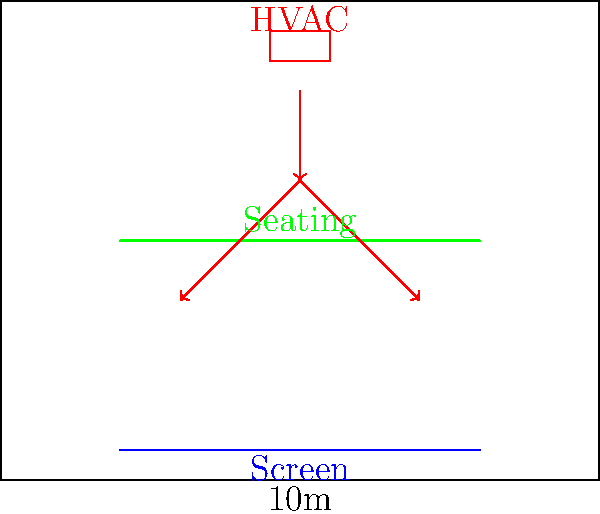In designing an energy-efficient HVAC system for your home theater room, you want to ensure optimal air distribution while minimizing noise. Given the floor plan shown, which of the following strategies would be most effective in achieving these goals?

A) Installing multiple small vents along the side walls
B) Using a single large vent directly above the seating area
C) Implementing a displacement ventilation system with low-velocity air supply near the floor
D) Placing high-velocity vents at the rear of the room, directed towards the screen Let's break down the problem and consider each option:

1. The room is relatively small (10m x 8m), which means we need to be careful about noise and air distribution.

2. Option A (multiple small vents along side walls):
   - Pros: Even distribution of air
   - Cons: Potential for drafts and noise from multiple sources

3. Option B (single large vent above seating):
   - Pros: Centralized air distribution
   - Cons: Potential for cold spots and uneven cooling

4. Option C (displacement ventilation with low-velocity air supply):
   - Pros: 
     - Quiet operation due to low air velocity
     - Efficient cooling as cool air naturally sinks
     - Improved air quality as contaminants rise with warm air
   - Cons: Requires careful design to avoid drafts

5. Option D (high-velocity vents at rear):
   - Pros: Good air circulation
   - Cons: Likely to create noise and potential discomfort for viewers

6. Considering the home theater environment:
   - Noise reduction is crucial for an enjoyable viewing experience
   - Even temperature distribution is important for comfort
   - Air movement should not interfere with sound quality or projection

7. The displacement ventilation system (Option C) offers the best balance:
   - It provides quiet operation, which is essential for a home theater
   - The low-velocity air supply minimizes interference with sound and projection
   - It naturally creates a temperature gradient that's comfortable for seated viewers
   - It can be designed to supply air from inconspicuous locations, maintaining the room's aesthetics

Therefore, the most effective strategy for this home theater room would be implementing a displacement ventilation system with low-velocity air supply near the floor.
Answer: C) Implementing a displacement ventilation system with low-velocity air supply near the floor 